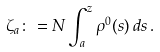<formula> <loc_0><loc_0><loc_500><loc_500>\zeta _ { a } \colon = N \int _ { a } ^ { z } \rho ^ { 0 } ( s ) \, d s \, .</formula> 